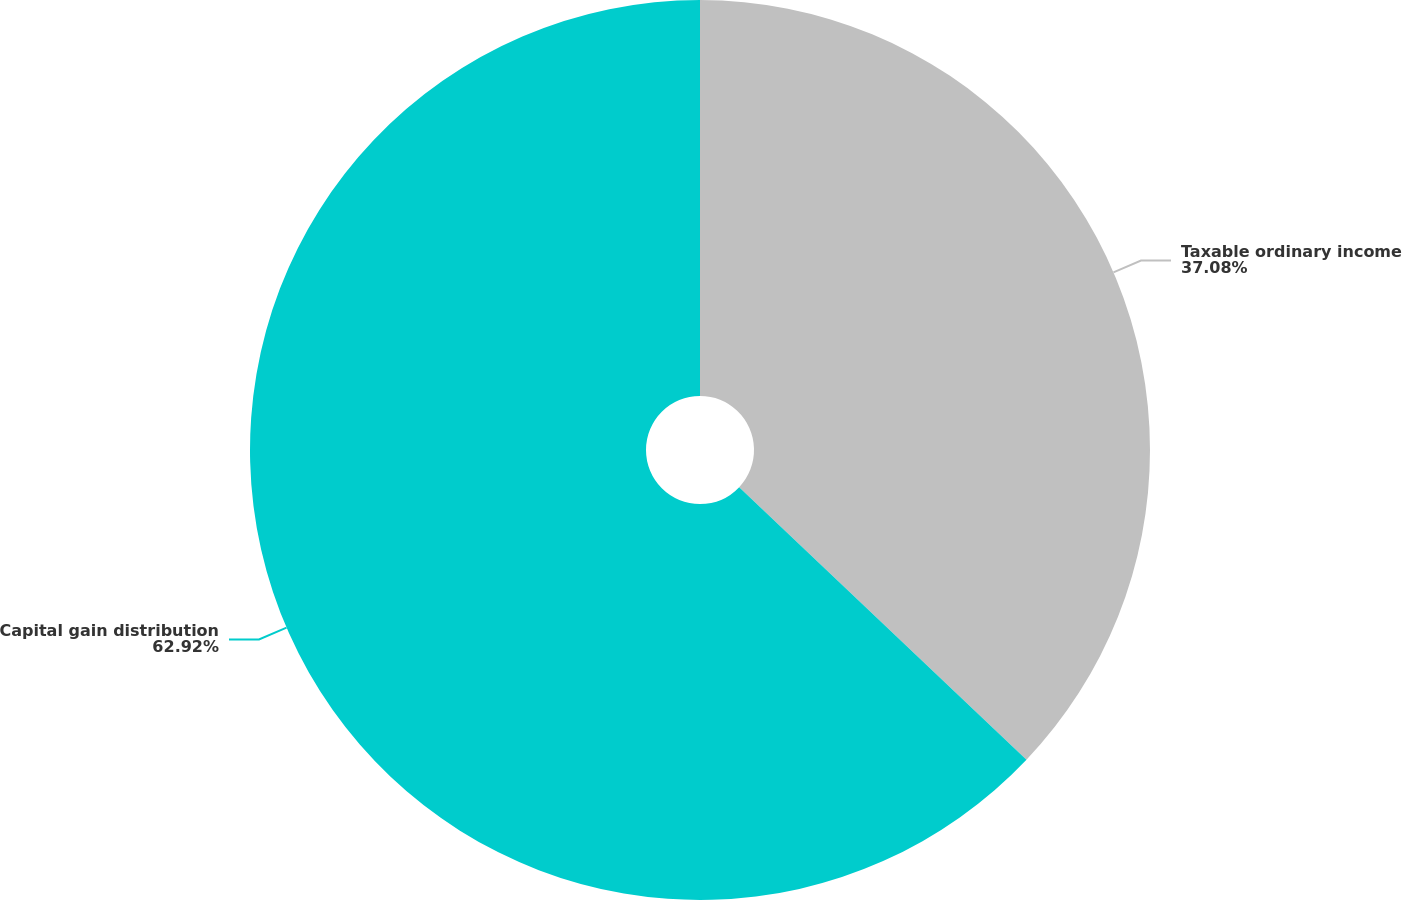<chart> <loc_0><loc_0><loc_500><loc_500><pie_chart><fcel>Taxable ordinary income<fcel>Capital gain distribution<nl><fcel>37.08%<fcel>62.92%<nl></chart> 